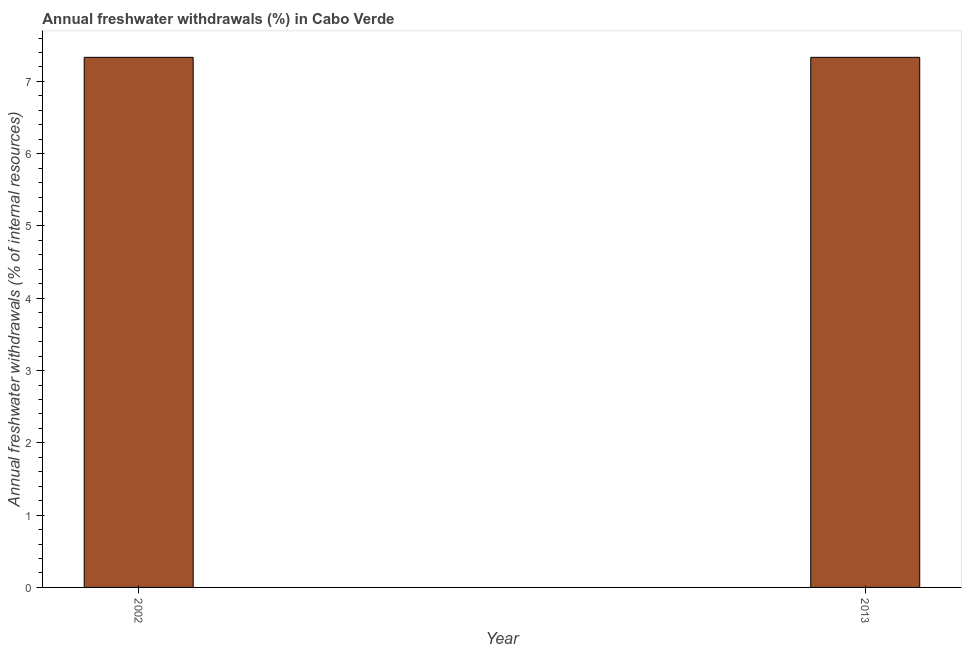Does the graph contain any zero values?
Provide a succinct answer. No. Does the graph contain grids?
Your response must be concise. No. What is the title of the graph?
Your answer should be compact. Annual freshwater withdrawals (%) in Cabo Verde. What is the label or title of the X-axis?
Your answer should be very brief. Year. What is the label or title of the Y-axis?
Keep it short and to the point. Annual freshwater withdrawals (% of internal resources). What is the annual freshwater withdrawals in 2002?
Make the answer very short. 7.33. Across all years, what is the maximum annual freshwater withdrawals?
Provide a short and direct response. 7.33. Across all years, what is the minimum annual freshwater withdrawals?
Offer a terse response. 7.33. In which year was the annual freshwater withdrawals minimum?
Provide a succinct answer. 2002. What is the sum of the annual freshwater withdrawals?
Give a very brief answer. 14.67. What is the difference between the annual freshwater withdrawals in 2002 and 2013?
Provide a short and direct response. 0. What is the average annual freshwater withdrawals per year?
Provide a short and direct response. 7.33. What is the median annual freshwater withdrawals?
Give a very brief answer. 7.33. What is the ratio of the annual freshwater withdrawals in 2002 to that in 2013?
Your response must be concise. 1. Is the annual freshwater withdrawals in 2002 less than that in 2013?
Offer a very short reply. No. How many bars are there?
Your response must be concise. 2. Are the values on the major ticks of Y-axis written in scientific E-notation?
Give a very brief answer. No. What is the Annual freshwater withdrawals (% of internal resources) of 2002?
Your response must be concise. 7.33. What is the Annual freshwater withdrawals (% of internal resources) in 2013?
Make the answer very short. 7.33. What is the ratio of the Annual freshwater withdrawals (% of internal resources) in 2002 to that in 2013?
Offer a very short reply. 1. 